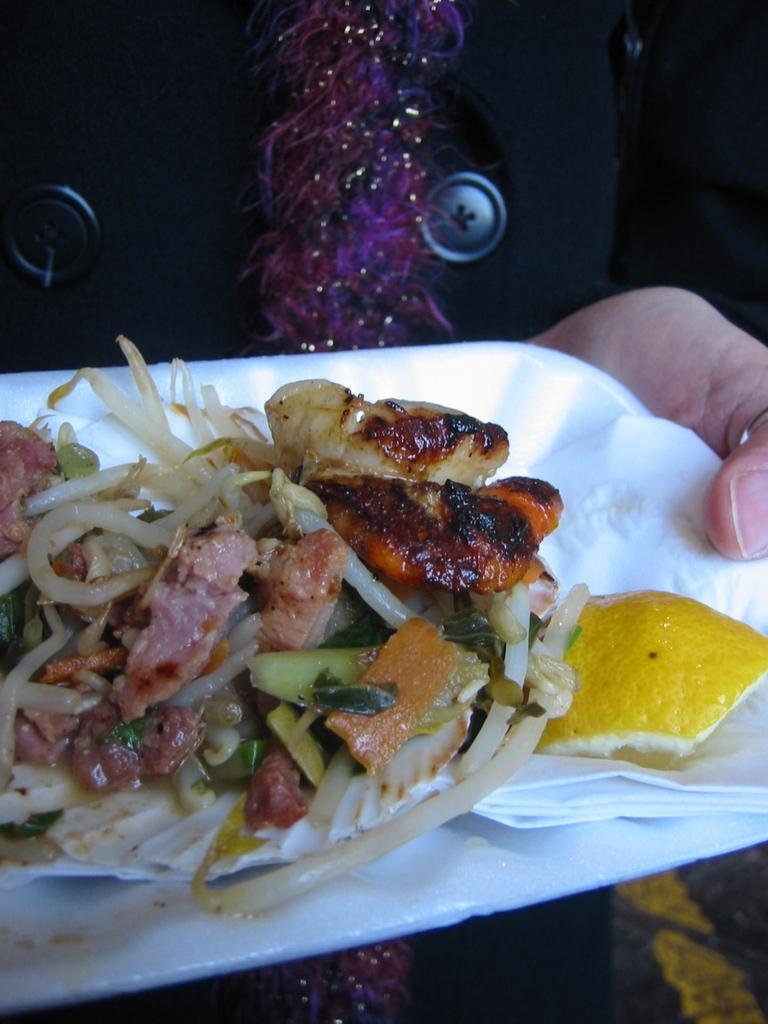Who or what is the main subject in the image? There is a person in the image. What is the person holding in the image? The person is holding a plate. What is on the plate that the person is holding? The plate has food on it, and there is also a paper on the plate. What type of design can be seen on the army uniform in the image? There is no army uniform or design present in the image. What is the person using the basin for in the image? There is no basin present in the image, so it cannot be used for any purpose. 